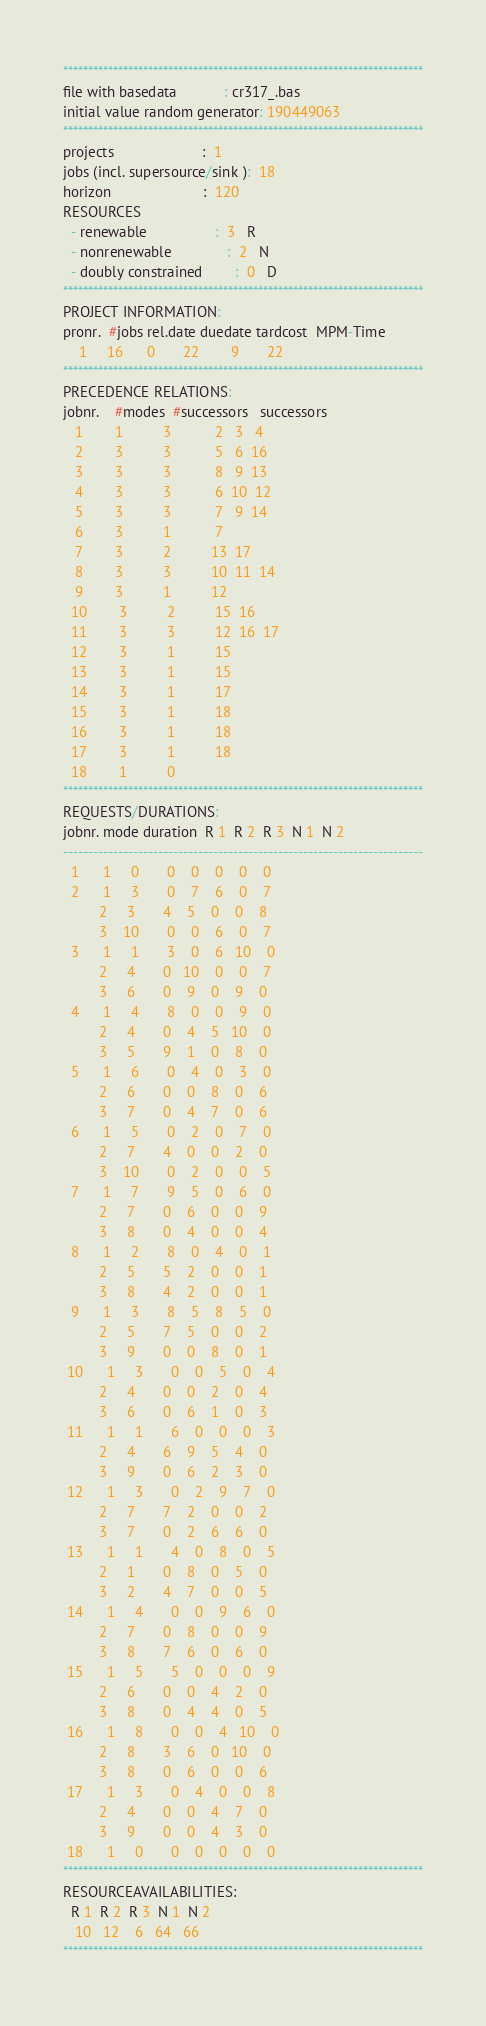<code> <loc_0><loc_0><loc_500><loc_500><_ObjectiveC_>************************************************************************
file with basedata            : cr317_.bas
initial value random generator: 190449063
************************************************************************
projects                      :  1
jobs (incl. supersource/sink ):  18
horizon                       :  120
RESOURCES
  - renewable                 :  3   R
  - nonrenewable              :  2   N
  - doubly constrained        :  0   D
************************************************************************
PROJECT INFORMATION:
pronr.  #jobs rel.date duedate tardcost  MPM-Time
    1     16      0       22        9       22
************************************************************************
PRECEDENCE RELATIONS:
jobnr.    #modes  #successors   successors
   1        1          3           2   3   4
   2        3          3           5   6  16
   3        3          3           8   9  13
   4        3          3           6  10  12
   5        3          3           7   9  14
   6        3          1           7
   7        3          2          13  17
   8        3          3          10  11  14
   9        3          1          12
  10        3          2          15  16
  11        3          3          12  16  17
  12        3          1          15
  13        3          1          15
  14        3          1          17
  15        3          1          18
  16        3          1          18
  17        3          1          18
  18        1          0        
************************************************************************
REQUESTS/DURATIONS:
jobnr. mode duration  R 1  R 2  R 3  N 1  N 2
------------------------------------------------------------------------
  1      1     0       0    0    0    0    0
  2      1     3       0    7    6    0    7
         2     3       4    5    0    0    8
         3    10       0    0    6    0    7
  3      1     1       3    0    6   10    0
         2     4       0   10    0    0    7
         3     6       0    9    0    9    0
  4      1     4       8    0    0    9    0
         2     4       0    4    5   10    0
         3     5       9    1    0    8    0
  5      1     6       0    4    0    3    0
         2     6       0    0    8    0    6
         3     7       0    4    7    0    6
  6      1     5       0    2    0    7    0
         2     7       4    0    0    2    0
         3    10       0    2    0    0    5
  7      1     7       9    5    0    6    0
         2     7       0    6    0    0    9
         3     8       0    4    0    0    4
  8      1     2       8    0    4    0    1
         2     5       5    2    0    0    1
         3     8       4    2    0    0    1
  9      1     3       8    5    8    5    0
         2     5       7    5    0    0    2
         3     9       0    0    8    0    1
 10      1     3       0    0    5    0    4
         2     4       0    0    2    0    4
         3     6       0    6    1    0    3
 11      1     1       6    0    0    0    3
         2     4       6    9    5    4    0
         3     9       0    6    2    3    0
 12      1     3       0    2    9    7    0
         2     7       7    2    0    0    2
         3     7       0    2    6    6    0
 13      1     1       4    0    8    0    5
         2     1       0    8    0    5    0
         3     2       4    7    0    0    5
 14      1     4       0    0    9    6    0
         2     7       0    8    0    0    9
         3     8       7    6    0    6    0
 15      1     5       5    0    0    0    9
         2     6       0    0    4    2    0
         3     8       0    4    4    0    5
 16      1     8       0    0    4   10    0
         2     8       3    6    0   10    0
         3     8       0    6    0    0    6
 17      1     3       0    4    0    0    8
         2     4       0    0    4    7    0
         3     9       0    0    4    3    0
 18      1     0       0    0    0    0    0
************************************************************************
RESOURCEAVAILABILITIES:
  R 1  R 2  R 3  N 1  N 2
   10   12    6   64   66
************************************************************************
</code> 